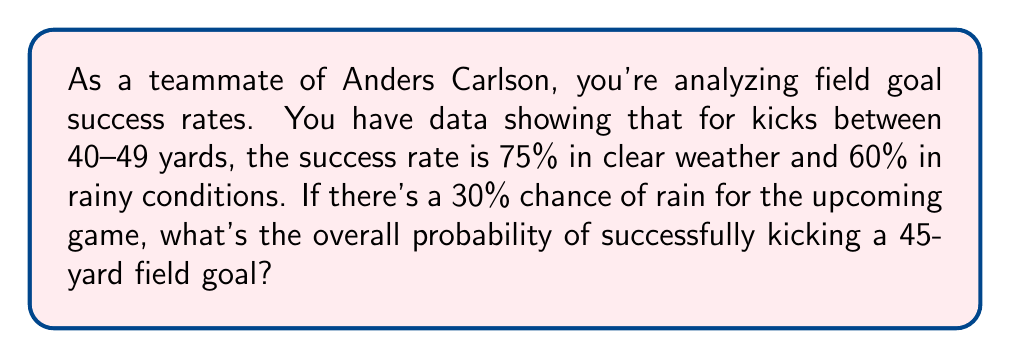What is the answer to this math problem? Let's approach this step-by-step using the law of total probability:

1) Define events:
   A: Successful field goal
   R: Rainy weather
   C: Clear weather

2) Given probabilities:
   P(A|C) = 0.75 (probability of success in clear weather)
   P(A|R) = 0.60 (probability of success in rainy weather)
   P(R) = 0.30 (probability of rain)
   P(C) = 1 - P(R) = 0.70 (probability of clear weather)

3) Law of Total Probability:
   $$P(A) = P(A|C) \cdot P(C) + P(A|R) \cdot P(R)$$

4) Substitute the values:
   $$P(A) = 0.75 \cdot 0.70 + 0.60 \cdot 0.30$$

5) Calculate:
   $$P(A) = 0.525 + 0.18 = 0.705$$

Therefore, the overall probability of successfully kicking a 45-yard field goal is 0.705 or 70.5%.
Answer: 0.705 or 70.5% 